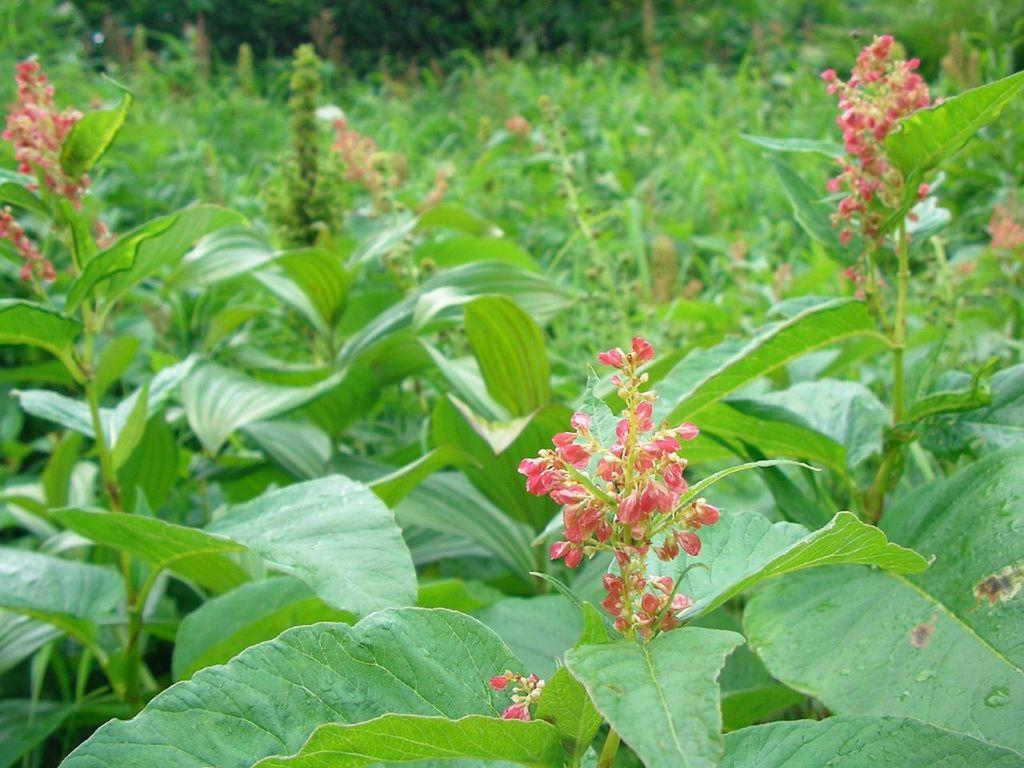What type of living organisms are present in the image? There are plants in the image. What specific parts of the plants can be seen? The plants have leaves and flowers. What type of bells can be heard ringing in the image? There are no bells present in the image, and therefore no sound can be heard. 